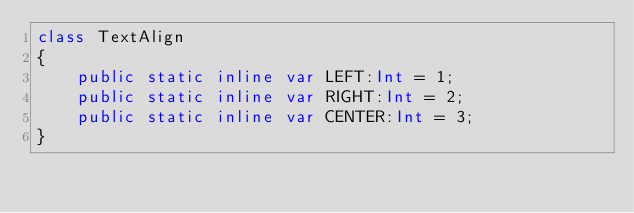Convert code to text. <code><loc_0><loc_0><loc_500><loc_500><_Haxe_>class TextAlign 
{
	public static inline var LEFT:Int = 1;
	public static inline var RIGHT:Int = 2;
	public static inline var CENTER:Int = 3;
}</code> 